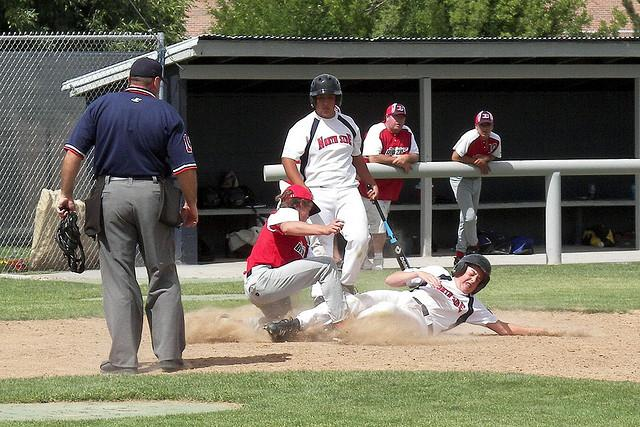Who famously helped win a 1992 playoff game doing what the boy in the black helmet is doing? sid bream 